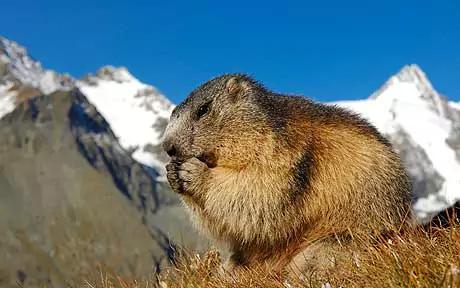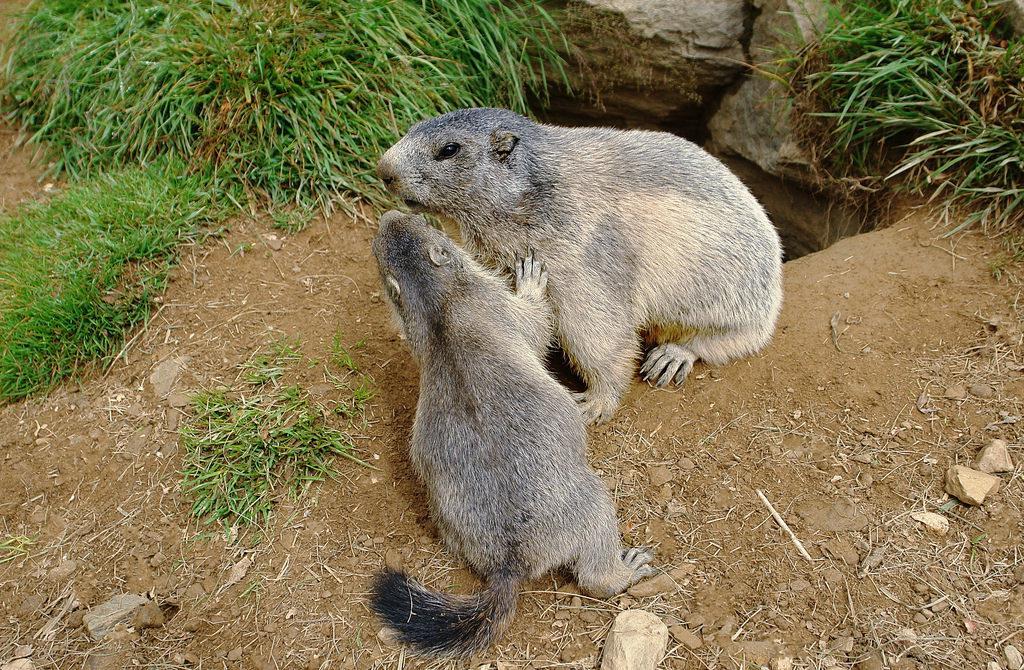The first image is the image on the left, the second image is the image on the right. Given the left and right images, does the statement "There are three marmots" hold true? Answer yes or no. Yes. The first image is the image on the left, the second image is the image on the right. For the images displayed, is the sentence "One image includes exactly twice as many marmots as the other image." factually correct? Answer yes or no. Yes. 